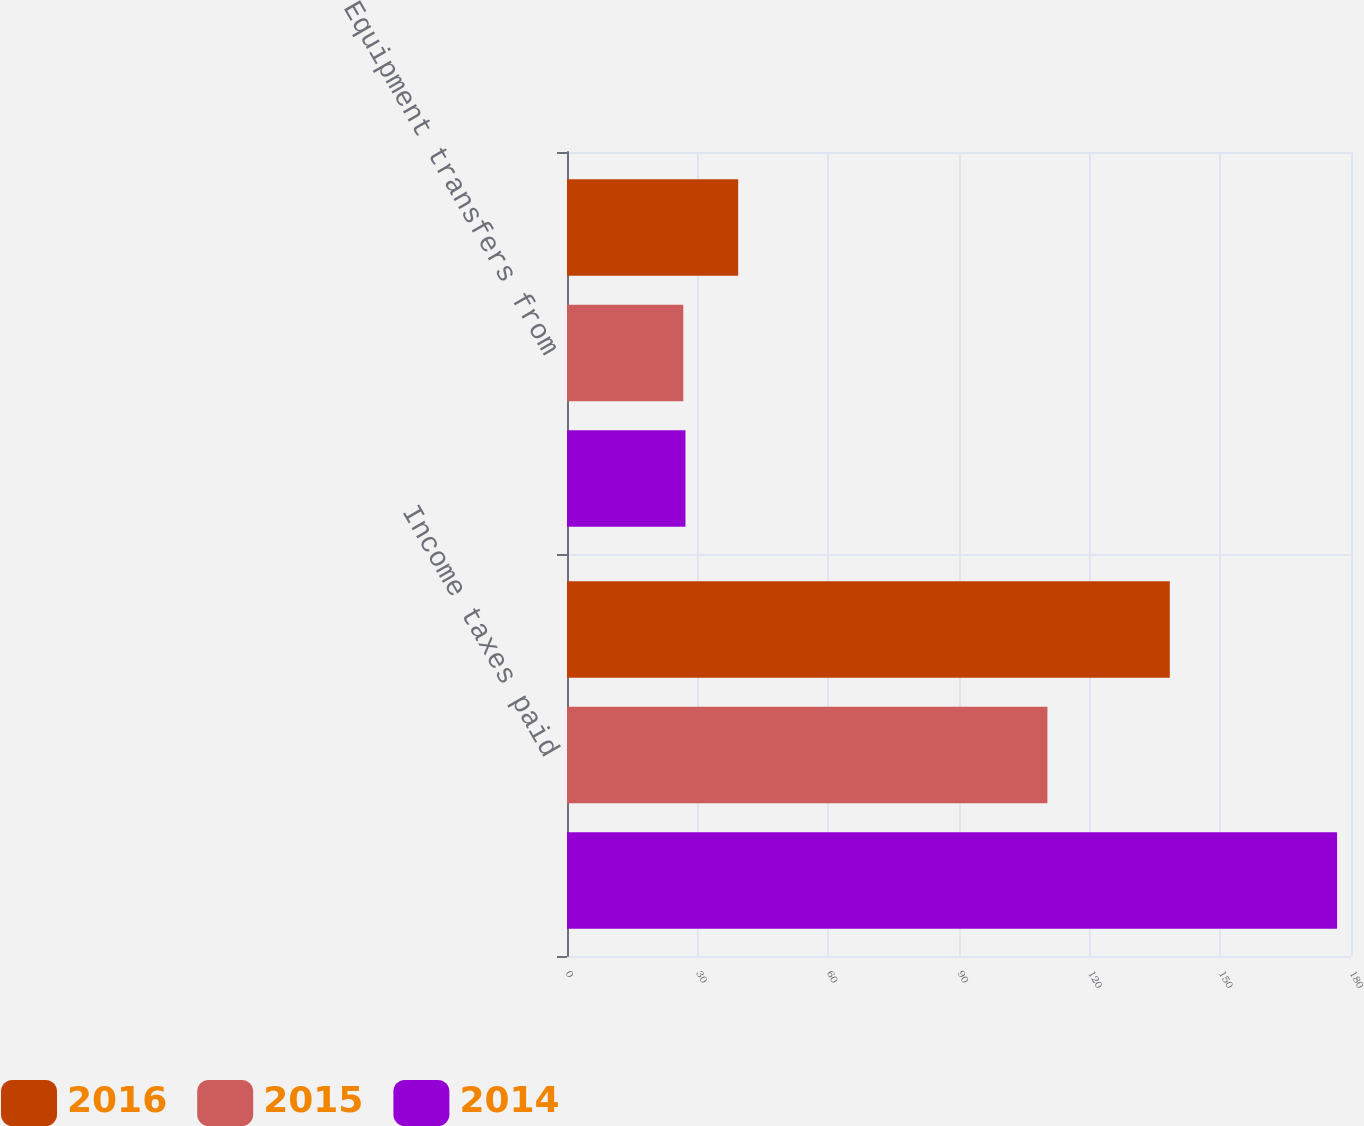<chart> <loc_0><loc_0><loc_500><loc_500><stacked_bar_chart><ecel><fcel>Income taxes paid<fcel>Equipment transfers from<nl><fcel>2016<fcel>138.4<fcel>39.3<nl><fcel>2015<fcel>110.3<fcel>26.7<nl><fcel>2014<fcel>176.8<fcel>27.2<nl></chart> 